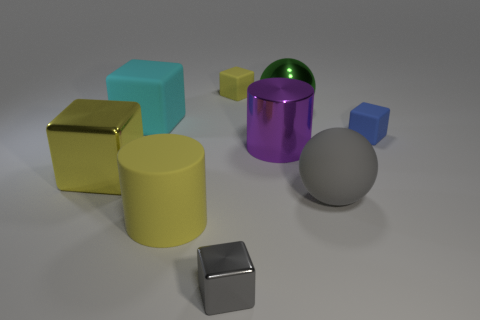Subtract all purple cubes. Subtract all green spheres. How many cubes are left? 5 Add 1 tiny gray cubes. How many objects exist? 10 Subtract all blocks. How many objects are left? 4 Add 4 metal cylinders. How many metal cylinders exist? 5 Subtract 0 cyan cylinders. How many objects are left? 9 Subtract all big yellow rubber things. Subtract all large cyan blocks. How many objects are left? 7 Add 9 large purple objects. How many large purple objects are left? 10 